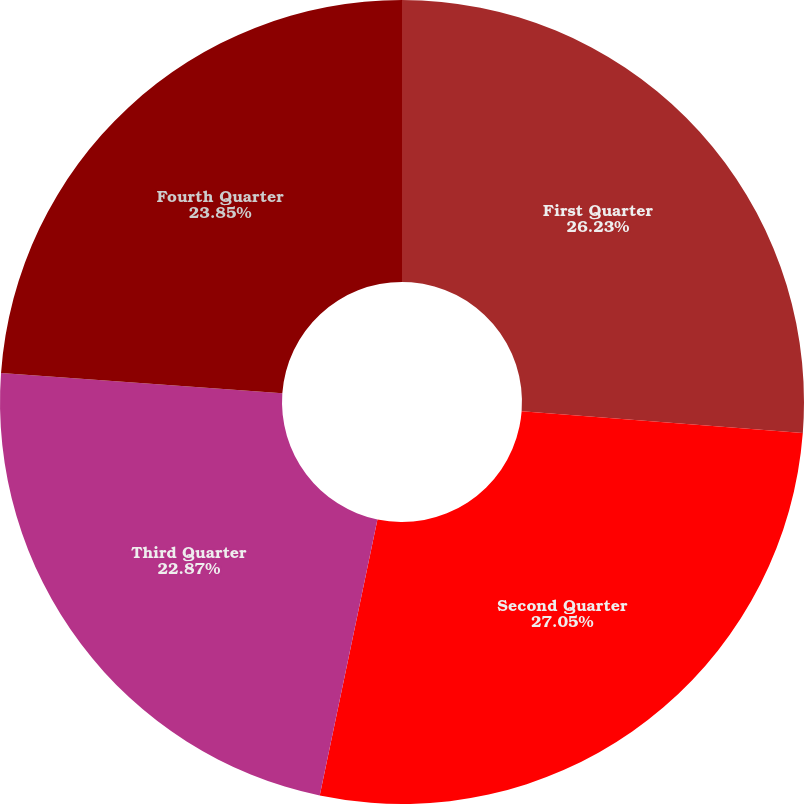<chart> <loc_0><loc_0><loc_500><loc_500><pie_chart><fcel>First Quarter<fcel>Second Quarter<fcel>Third Quarter<fcel>Fourth Quarter<nl><fcel>26.23%<fcel>27.05%<fcel>22.87%<fcel>23.85%<nl></chart> 